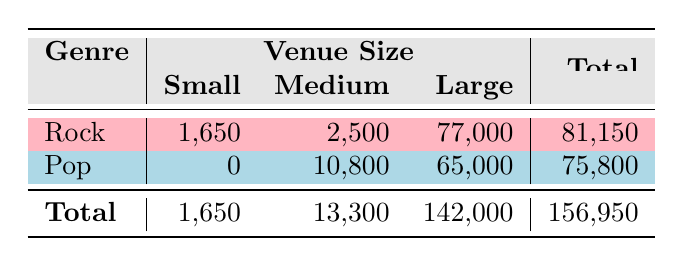What is the total attendance for rock concerts? To find the total attendance for rock concerts, I will add the values from the "Small," "Medium," and "Large" categories under the "Rock" genre. The totals are 1,650 (Small) + 2,500 (Medium) + 77,000 (Large) = 81,150.
Answer: 81,150 What is the total attendance for pop concerts in medium-sized venues? The attendance for pop concerts in medium-sized venues can be found directly from the "Medium" column for the "Pop" genre, which is 10,800.
Answer: 10,800 Are there any small pop concerts recorded in this data? Looking at the "Pop" genre in the table, there are no recorded small venues as the value under "Small" is 0.
Answer: No Which genre has the highest total attendance? I will compare the total attendance for both genres: Rock has 81,150 and Pop has 75,800. Rock has the higher attendance.
Answer: Rock What is the average attendance for large concerts across both genres? To find the average attendance for large concerts, I will sum the large venue attendances: 77,000 (Rock) + 65,000 (Pop) = 142,000, and then divide by the number of genres (2). The average attendance is 142,000 / 2 = 71,000.
Answer: 71,000 Are the total attendances of small venues greater than those of medium venues? Adding the values for small venues gives 1,650 (Rock) and 0 (Pop) = 1,650. For medium venues, the total is 2,500 (Rock) + 10,800 (Pop) = 13,300. Since 1,650 is less than 13,300, the statement is false.
Answer: No What is the total revenue generated from the rock concerts? I will multiply the attendance by the ticket price for rock concerts: (1,650 * 25) + (2,500 * 65) + (77,000 * 85) = 41,250 + 162,500 + 6,545,000 = 6,748,750.
Answer: 6,748,750 How many more people attended large concerts compared to small concerts overall? To find this, I need to add the attendances for both genres in large venues (142,000) and small venues (1,650). The difference is 142,000 - 1,650 = 140,350.
Answer: 140,350 